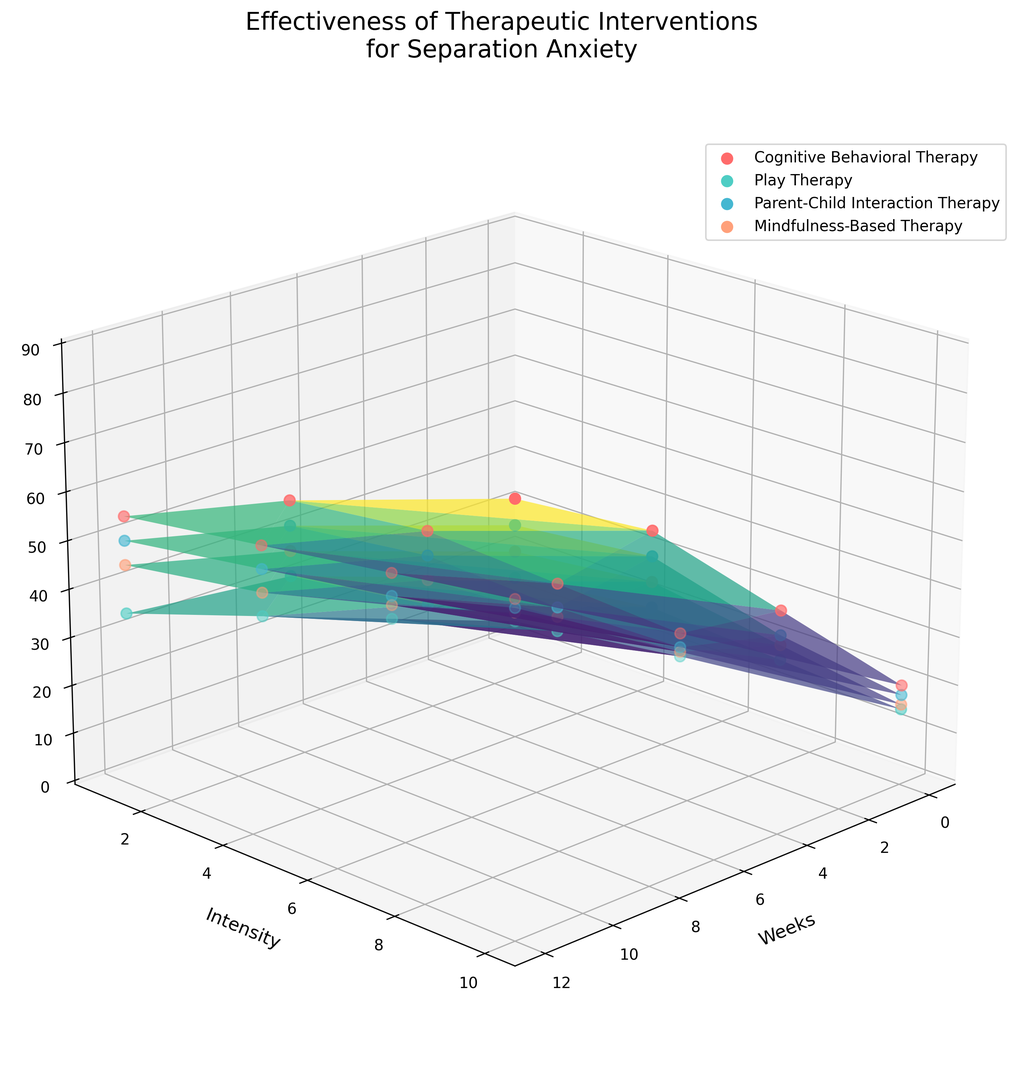What's the trend in effectiveness of Cognitive Behavioral Therapy over 12 weeks? To determine the trend, observe the effectiveness of Cognitive Behavioral Therapy at weeks 0, 4, 8, and 12. Effectiveness increases from 10-20 at week 0, 25-45 at week 4, 40-70 at week 8, to 55-85 at week 12.
Answer: Increasing Which therapy shows a green surface, indicating higher effectiveness in general? By visual inspection, the greenish color is dominant on the surface of Cognitive Behavioral Therapy across various weeks and intensities, suggesting it is more effective.
Answer: Cognitive Behavioral Therapy How does the effectiveness of Play Therapy at week 8 and intensity 5 compare to Parent-Child Interaction Therapy at the same week and intensity? Look at the effectiveness values for Play Therapy and Parent-Child Interaction Therapy at week 8 and intensity 5. Play Therapy has an effectiveness of 40; Parent-Child Interaction Therapy has an effectiveness of 50.
Answer: Parent-Child Interaction Therapy is more effective Which therapy reaches an effectiveness of 75 after 12 weeks at the highest intensity? Review the effectiveness at week 12 and intensity 10 for all therapies. Mindfulness-Based Therapy shows an effectiveness of 75 at this point.
Answer: Mindfulness-Based Therapy Across all therapies, which one shows the least initial effectiveness at zero weeks and low intensity? Check the effectiveness values at week 0 and intensity 1. Play Therapy starts at an effectiveness of 5, lower than the others.
Answer: Play Therapy If combining the effectiveness of Cognitive Behavioral Therapy and Parent-Child Interaction Therapy at week 4 and intensity 10, what is the total effectiveness? Add the effectiveness values of both therapies at week 4 and intensity 10. Cognitive Behavioral Therapy: 45; Parent-Child Interaction Therapy: 40; Total: 45 + 40 = 85.
Answer: 85 Which two therapies have overlapping effectiveness ranges at week 12, intensity 5? Compare effectiveness at week 12, intensity 5. Cognitive Behavioral Therapy (70) and Parent-Child Interaction Therapy (65) share overlapping ranges close together.
Answer: Cognitive Behavioral Therapy and Parent-Child Interaction Therapy At what week does Mindfulness-Based Therapy reach an effectiveness of 45 at both low and medium intensities? Look for weeks where effectiveness for Mindfulness-Based Therapy is 45 at intensities 1 and 5. At week 8, effectiveness at intensity 1 is 30 and 45 at intensity 5.
Answer: Week 8 How does the effectiveness change for Cognitive Behavioral Therapy from week 0 to week 4 at the highest intensity? Review the effectiveness of Cognitive Behavioral Therapy at intensity 10 for weeks 0 and 4. It changes from 20 at week 0 to 45 at week 4.
Answer: Increases by 25 